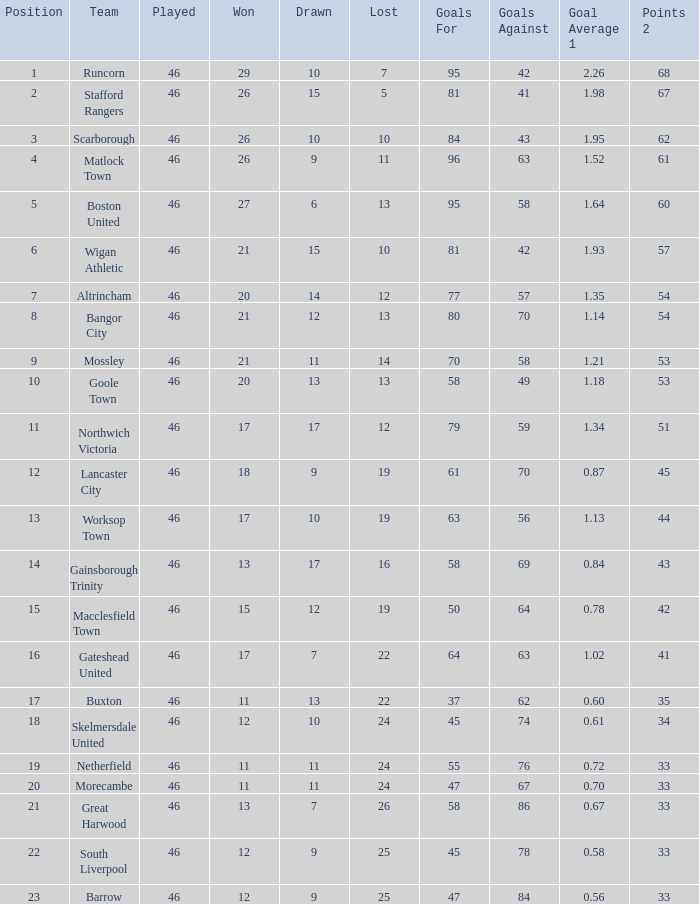Which team possessed goal averages of Northwich Victoria. 